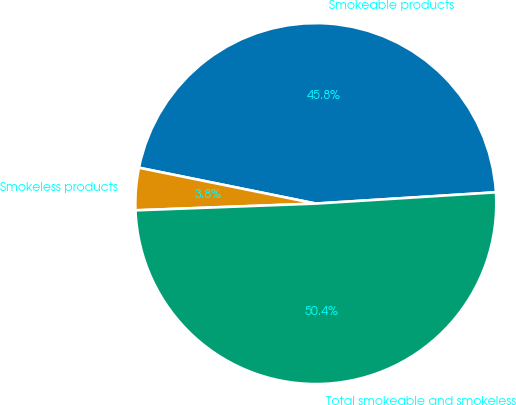Convert chart to OTSL. <chart><loc_0><loc_0><loc_500><loc_500><pie_chart><fcel>Smokeable products<fcel>Smokeless products<fcel>Total smokeable and smokeless<nl><fcel>45.82%<fcel>3.78%<fcel>50.4%<nl></chart> 